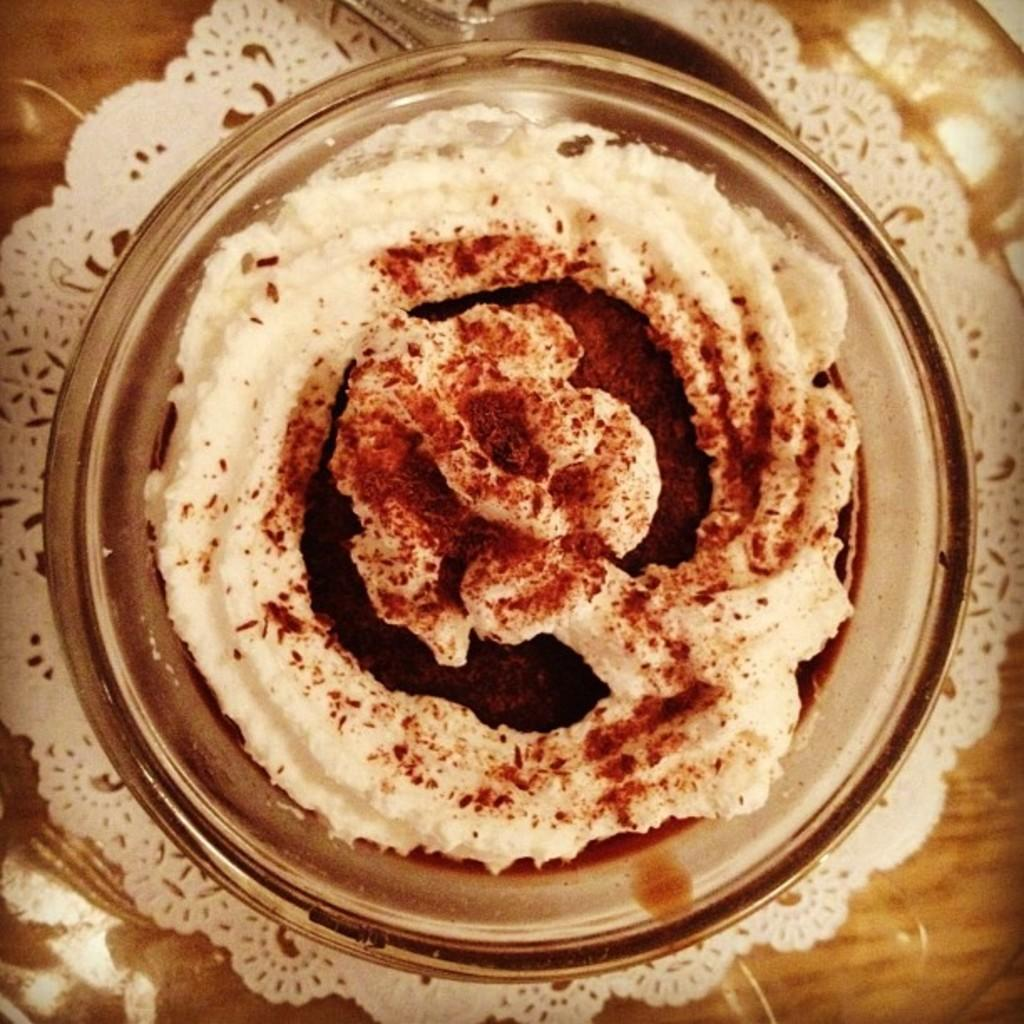What is in the bowl that is visible in the image? There is a food item in a bowl in the image. Where is the bowl located? The bowl is on a dining mat. What surface is the dining mat placed on? The dining mat is on a table. What songs are the ducks singing in the image? There are no ducks or songs present in the image. 